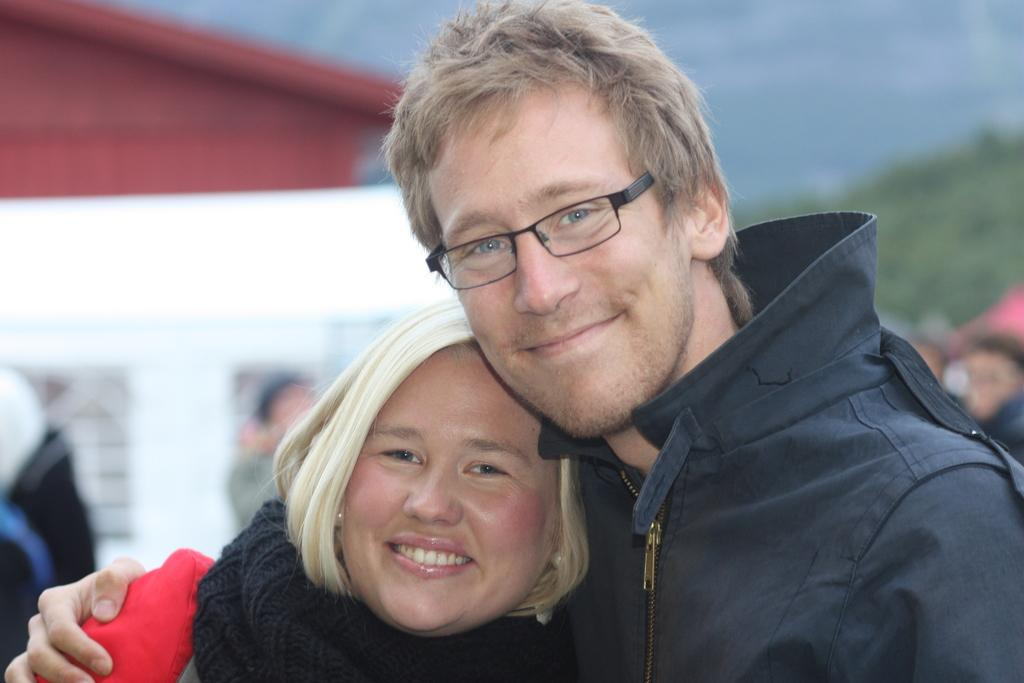How many people are visible in the image? There are two people in the image. Are there any other people present in the image besides the two mentioned? Yes, there are other people in the image. Can you describe the background of the image? The background of the image is blurred. What type of camera is being used to take the picture of the island in the image? There is no island or camera present in the image; it features two people and other people in a blurred background. 